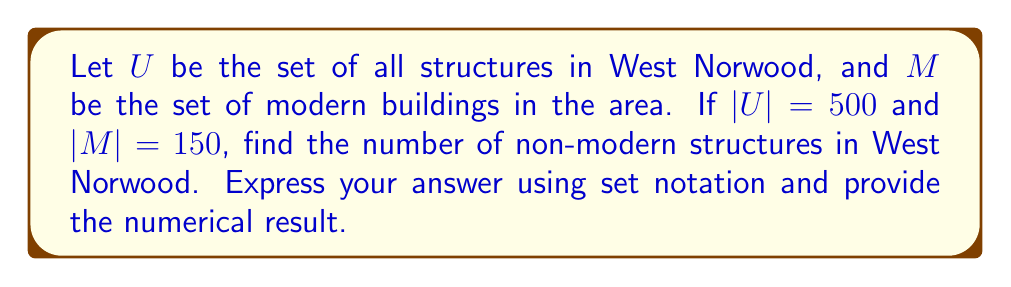Provide a solution to this math problem. To solve this problem, we need to understand the concept of set complement and apply it to the given scenario:

1) The complement of set $M$ relative to set $U$ is denoted as $M^c$ or $U \setminus M$. This represents all elements in $U$ that are not in $M$.

2) In this case, $M^c$ represents all non-modern structures in West Norwood.

3) We know that:
   $|U| = 500$ (total number of structures)
   $|M| = 150$ (number of modern buildings)

4) To find $|M^c|$, we can use the following formula:
   $$|M^c| = |U| - |M|$$

5) Substituting the known values:
   $$|M^c| = 500 - 150 = 350$$

Therefore, there are 350 non-modern structures in West Norwood.

In set notation, we can express this as:
$$|U \setminus M| = 350$$
Answer: $|U \setminus M| = 350$ 